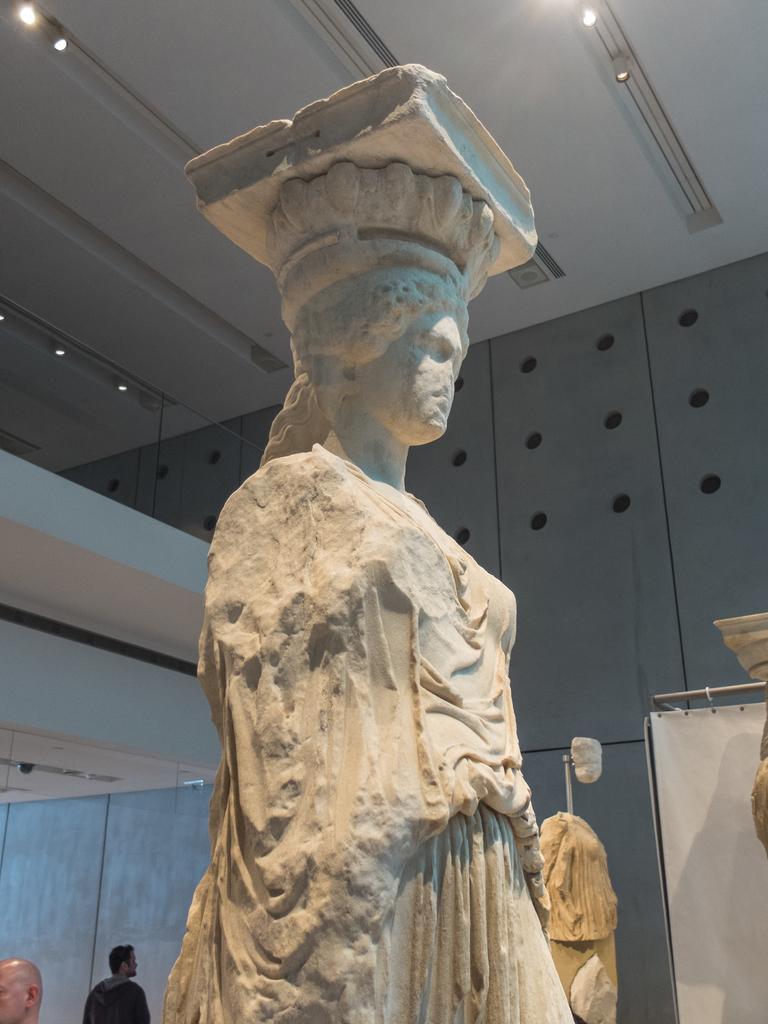In one or two sentences, can you explain what this image depicts? As we can see in the image there is wall, statue and on the left side there are two persons standing. At the top there are lights. On the right side there is white color cloth. 